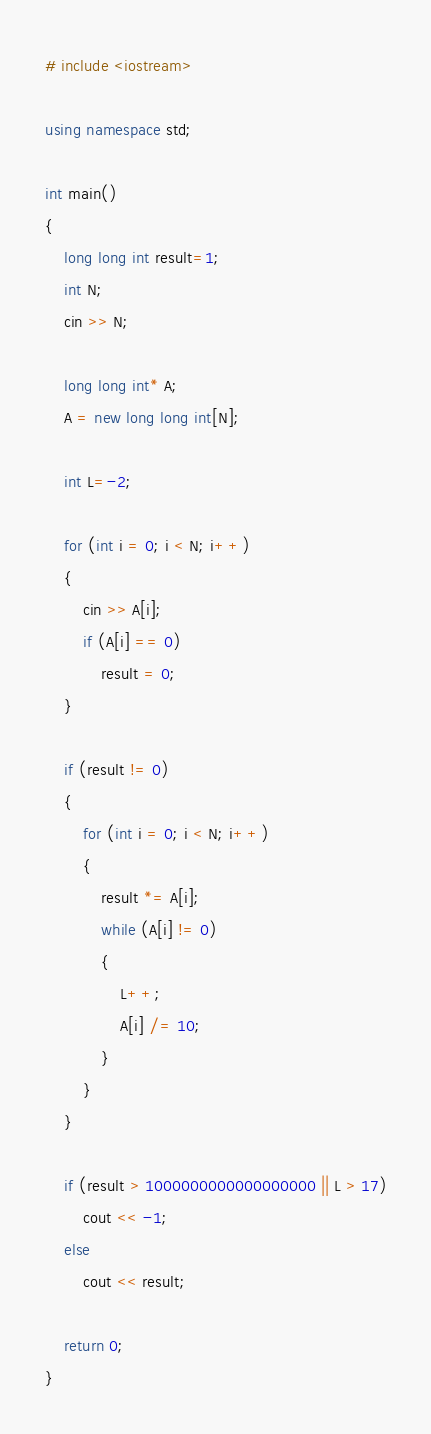Convert code to text. <code><loc_0><loc_0><loc_500><loc_500><_C++_># include <iostream>

using namespace std;

int main()
{
	long long int result=1;
	int N;
	cin >> N;

	long long int* A;
	A = new long long int[N];

	int L=-2;

	for (int i = 0; i < N; i++)
	{
		cin >> A[i];
		if (A[i] == 0)
			result = 0;
	}

	if (result != 0)
	{
		for (int i = 0; i < N; i++)
		{
			result *= A[i];
			while (A[i] != 0)
			{
				L++;
				A[i] /= 10;
			}
		}
	}

	if (result > 1000000000000000000 || L > 17)
		cout << -1;
	else	
		cout << result;

    return 0;
}</code> 